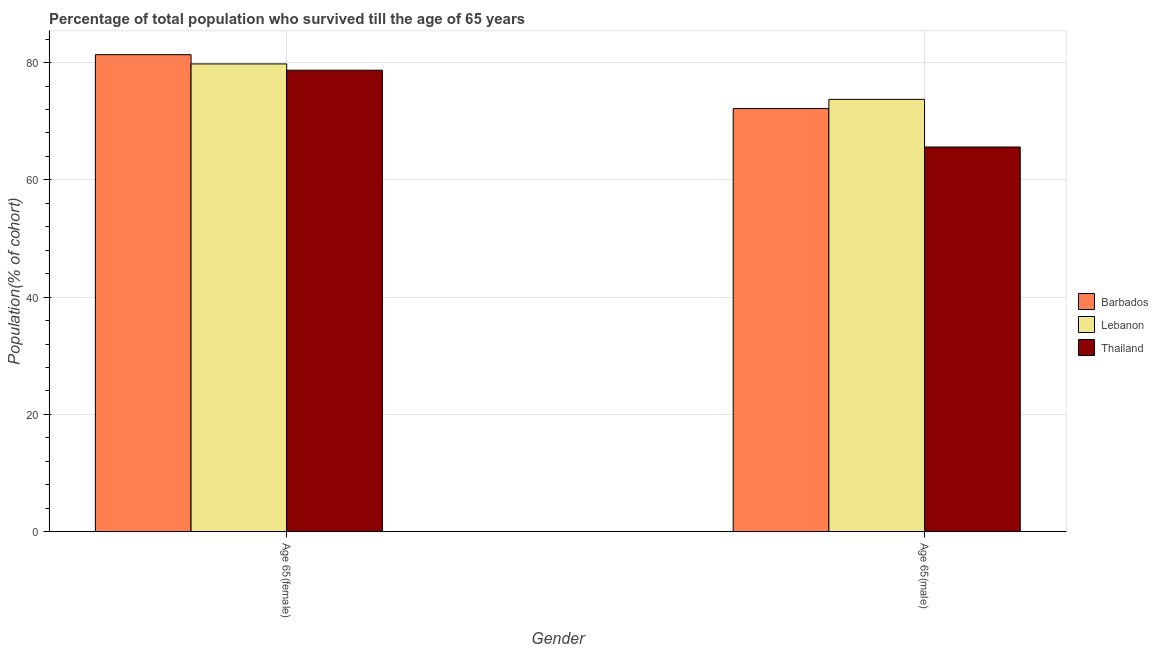How many different coloured bars are there?
Provide a short and direct response. 3. How many groups of bars are there?
Provide a succinct answer. 2. How many bars are there on the 1st tick from the left?
Your response must be concise. 3. What is the label of the 2nd group of bars from the left?
Make the answer very short. Age 65(male). What is the percentage of female population who survived till age of 65 in Thailand?
Your answer should be very brief. 78.71. Across all countries, what is the maximum percentage of male population who survived till age of 65?
Offer a terse response. 73.73. Across all countries, what is the minimum percentage of female population who survived till age of 65?
Your answer should be very brief. 78.71. In which country was the percentage of male population who survived till age of 65 maximum?
Provide a succinct answer. Lebanon. In which country was the percentage of female population who survived till age of 65 minimum?
Provide a succinct answer. Thailand. What is the total percentage of female population who survived till age of 65 in the graph?
Your response must be concise. 239.84. What is the difference between the percentage of male population who survived till age of 65 in Lebanon and that in Barbados?
Your answer should be very brief. 1.57. What is the difference between the percentage of male population who survived till age of 65 in Thailand and the percentage of female population who survived till age of 65 in Barbados?
Your answer should be compact. -15.75. What is the average percentage of female population who survived till age of 65 per country?
Your answer should be compact. 79.95. What is the difference between the percentage of male population who survived till age of 65 and percentage of female population who survived till age of 65 in Barbados?
Your response must be concise. -9.19. What is the ratio of the percentage of male population who survived till age of 65 in Lebanon to that in Thailand?
Your answer should be very brief. 1.12. What does the 1st bar from the left in Age 65(male) represents?
Offer a terse response. Barbados. What does the 1st bar from the right in Age 65(female) represents?
Offer a terse response. Thailand. How many bars are there?
Ensure brevity in your answer.  6. How many countries are there in the graph?
Your answer should be compact. 3. Does the graph contain grids?
Offer a very short reply. Yes. Where does the legend appear in the graph?
Your answer should be compact. Center right. How many legend labels are there?
Provide a succinct answer. 3. What is the title of the graph?
Make the answer very short. Percentage of total population who survived till the age of 65 years. Does "Saudi Arabia" appear as one of the legend labels in the graph?
Make the answer very short. No. What is the label or title of the Y-axis?
Offer a terse response. Population(% of cohort). What is the Population(% of cohort) in Barbados in Age 65(female)?
Your response must be concise. 81.35. What is the Population(% of cohort) of Lebanon in Age 65(female)?
Offer a terse response. 79.78. What is the Population(% of cohort) in Thailand in Age 65(female)?
Provide a short and direct response. 78.71. What is the Population(% of cohort) of Barbados in Age 65(male)?
Make the answer very short. 72.16. What is the Population(% of cohort) of Lebanon in Age 65(male)?
Offer a terse response. 73.73. What is the Population(% of cohort) of Thailand in Age 65(male)?
Offer a very short reply. 65.61. Across all Gender, what is the maximum Population(% of cohort) of Barbados?
Offer a very short reply. 81.35. Across all Gender, what is the maximum Population(% of cohort) of Lebanon?
Offer a very short reply. 79.78. Across all Gender, what is the maximum Population(% of cohort) of Thailand?
Offer a terse response. 78.71. Across all Gender, what is the minimum Population(% of cohort) in Barbados?
Offer a terse response. 72.16. Across all Gender, what is the minimum Population(% of cohort) in Lebanon?
Your answer should be compact. 73.73. Across all Gender, what is the minimum Population(% of cohort) of Thailand?
Keep it short and to the point. 65.61. What is the total Population(% of cohort) of Barbados in the graph?
Your response must be concise. 153.52. What is the total Population(% of cohort) of Lebanon in the graph?
Keep it short and to the point. 153.51. What is the total Population(% of cohort) in Thailand in the graph?
Ensure brevity in your answer.  144.31. What is the difference between the Population(% of cohort) of Barbados in Age 65(female) and that in Age 65(male)?
Your response must be concise. 9.19. What is the difference between the Population(% of cohort) in Lebanon in Age 65(female) and that in Age 65(male)?
Make the answer very short. 6.05. What is the difference between the Population(% of cohort) in Thailand in Age 65(female) and that in Age 65(male)?
Provide a short and direct response. 13.1. What is the difference between the Population(% of cohort) of Barbados in Age 65(female) and the Population(% of cohort) of Lebanon in Age 65(male)?
Ensure brevity in your answer.  7.62. What is the difference between the Population(% of cohort) of Barbados in Age 65(female) and the Population(% of cohort) of Thailand in Age 65(male)?
Your answer should be very brief. 15.75. What is the difference between the Population(% of cohort) in Lebanon in Age 65(female) and the Population(% of cohort) in Thailand in Age 65(male)?
Provide a short and direct response. 14.17. What is the average Population(% of cohort) of Barbados per Gender?
Your answer should be compact. 76.76. What is the average Population(% of cohort) in Lebanon per Gender?
Your answer should be very brief. 76.76. What is the average Population(% of cohort) in Thailand per Gender?
Ensure brevity in your answer.  72.16. What is the difference between the Population(% of cohort) of Barbados and Population(% of cohort) of Lebanon in Age 65(female)?
Offer a terse response. 1.58. What is the difference between the Population(% of cohort) of Barbados and Population(% of cohort) of Thailand in Age 65(female)?
Provide a succinct answer. 2.65. What is the difference between the Population(% of cohort) of Lebanon and Population(% of cohort) of Thailand in Age 65(female)?
Keep it short and to the point. 1.07. What is the difference between the Population(% of cohort) of Barbados and Population(% of cohort) of Lebanon in Age 65(male)?
Provide a short and direct response. -1.57. What is the difference between the Population(% of cohort) of Barbados and Population(% of cohort) of Thailand in Age 65(male)?
Keep it short and to the point. 6.55. What is the difference between the Population(% of cohort) in Lebanon and Population(% of cohort) in Thailand in Age 65(male)?
Offer a very short reply. 8.12. What is the ratio of the Population(% of cohort) in Barbados in Age 65(female) to that in Age 65(male)?
Your answer should be very brief. 1.13. What is the ratio of the Population(% of cohort) of Lebanon in Age 65(female) to that in Age 65(male)?
Keep it short and to the point. 1.08. What is the ratio of the Population(% of cohort) of Thailand in Age 65(female) to that in Age 65(male)?
Provide a short and direct response. 1.2. What is the difference between the highest and the second highest Population(% of cohort) of Barbados?
Provide a succinct answer. 9.19. What is the difference between the highest and the second highest Population(% of cohort) of Lebanon?
Provide a succinct answer. 6.05. What is the difference between the highest and the second highest Population(% of cohort) in Thailand?
Offer a very short reply. 13.1. What is the difference between the highest and the lowest Population(% of cohort) in Barbados?
Your answer should be compact. 9.19. What is the difference between the highest and the lowest Population(% of cohort) of Lebanon?
Your answer should be very brief. 6.05. What is the difference between the highest and the lowest Population(% of cohort) of Thailand?
Provide a succinct answer. 13.1. 